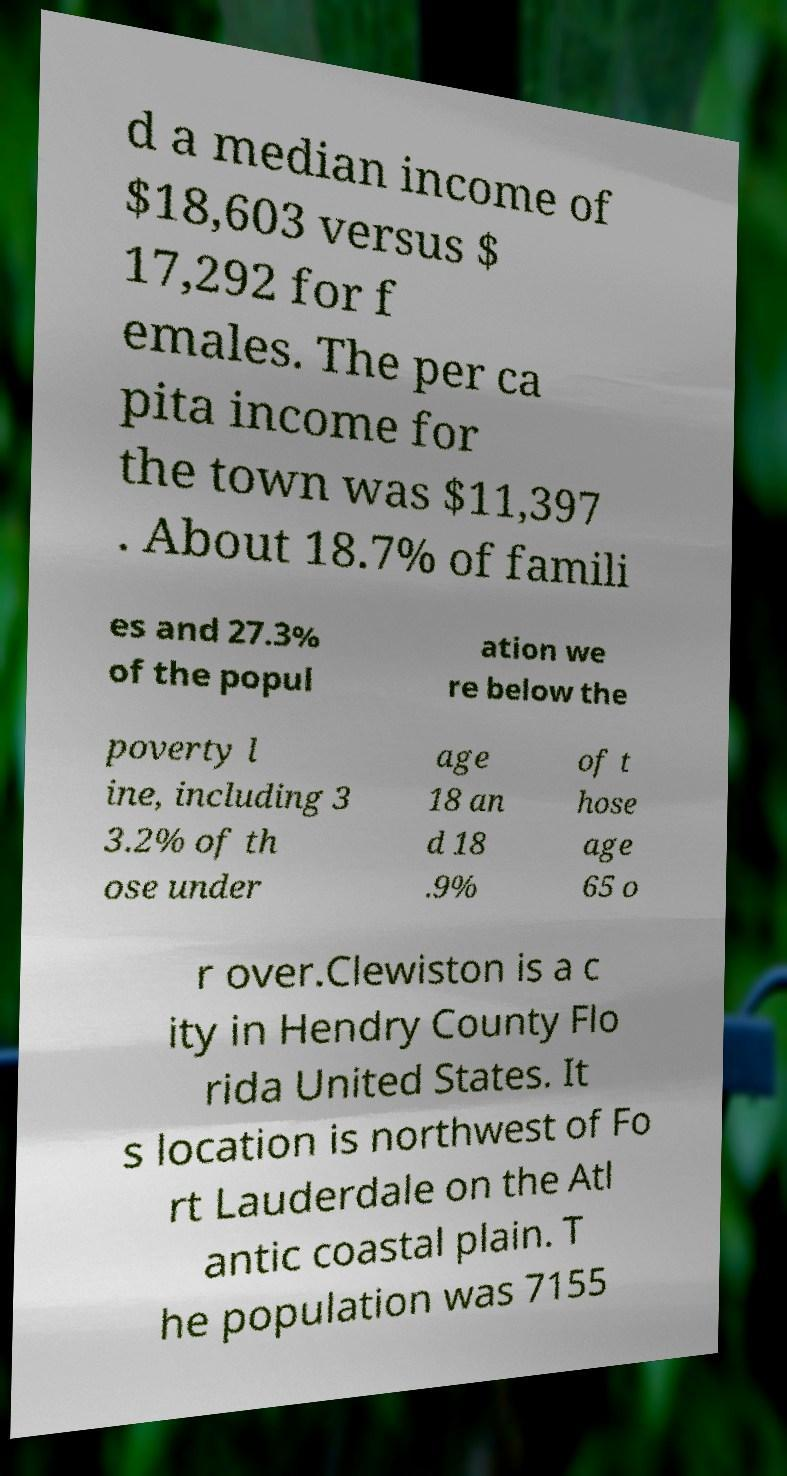What messages or text are displayed in this image? I need them in a readable, typed format. d a median income of $18,603 versus $ 17,292 for f emales. The per ca pita income for the town was $11,397 . About 18.7% of famili es and 27.3% of the popul ation we re below the poverty l ine, including 3 3.2% of th ose under age 18 an d 18 .9% of t hose age 65 o r over.Clewiston is a c ity in Hendry County Flo rida United States. It s location is northwest of Fo rt Lauderdale on the Atl antic coastal plain. T he population was 7155 